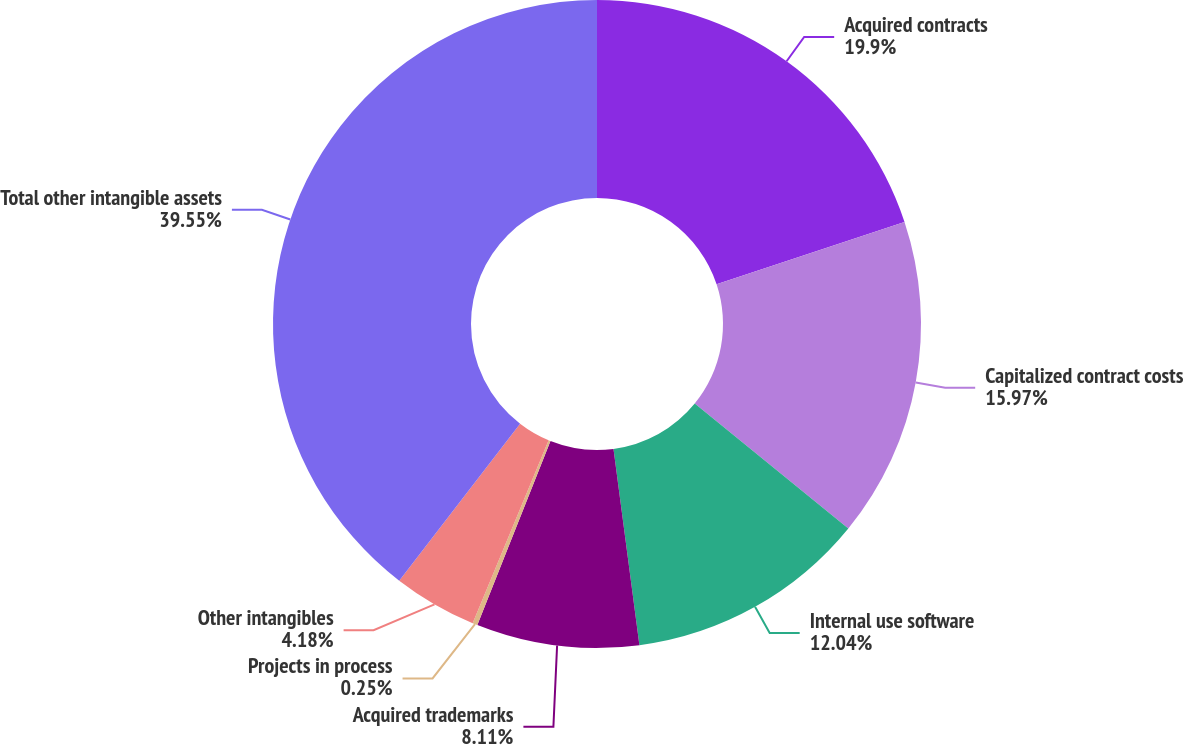Convert chart to OTSL. <chart><loc_0><loc_0><loc_500><loc_500><pie_chart><fcel>Acquired contracts<fcel>Capitalized contract costs<fcel>Internal use software<fcel>Acquired trademarks<fcel>Projects in process<fcel>Other intangibles<fcel>Total other intangible assets<nl><fcel>19.9%<fcel>15.97%<fcel>12.04%<fcel>8.11%<fcel>0.25%<fcel>4.18%<fcel>39.55%<nl></chart> 